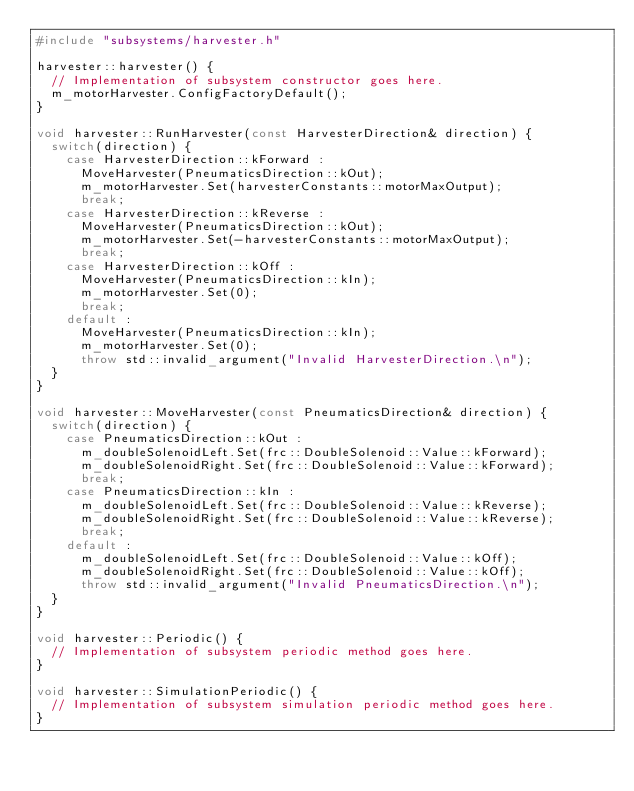<code> <loc_0><loc_0><loc_500><loc_500><_C++_>#include "subsystems/harvester.h"

harvester::harvester() {
  // Implementation of subsystem constructor goes here.
  m_motorHarvester.ConfigFactoryDefault();
}

void harvester::RunHarvester(const HarvesterDirection& direction) {
  switch(direction) {
    case HarvesterDirection::kForward :
      MoveHarvester(PneumaticsDirection::kOut);
      m_motorHarvester.Set(harvesterConstants::motorMaxOutput);
      break;
    case HarvesterDirection::kReverse :
      MoveHarvester(PneumaticsDirection::kOut);
      m_motorHarvester.Set(-harvesterConstants::motorMaxOutput);
      break;
    case HarvesterDirection::kOff :
      MoveHarvester(PneumaticsDirection::kIn);
      m_motorHarvester.Set(0);
      break;
    default :
      MoveHarvester(PneumaticsDirection::kIn);
      m_motorHarvester.Set(0);
      throw std::invalid_argument("Invalid HarvesterDirection.\n");
  }
}

void harvester::MoveHarvester(const PneumaticsDirection& direction) {
  switch(direction) {
    case PneumaticsDirection::kOut :
      m_doubleSolenoidLeft.Set(frc::DoubleSolenoid::Value::kForward);
      m_doubleSolenoidRight.Set(frc::DoubleSolenoid::Value::kForward);
      break;
    case PneumaticsDirection::kIn :
      m_doubleSolenoidLeft.Set(frc::DoubleSolenoid::Value::kReverse);
      m_doubleSolenoidRight.Set(frc::DoubleSolenoid::Value::kReverse);
      break;
    default :
      m_doubleSolenoidLeft.Set(frc::DoubleSolenoid::Value::kOff);
      m_doubleSolenoidRight.Set(frc::DoubleSolenoid::Value::kOff);
      throw std::invalid_argument("Invalid PneumaticsDirection.\n");
  }
}

void harvester::Periodic() {
  // Implementation of subsystem periodic method goes here.
}

void harvester::SimulationPeriodic() {
  // Implementation of subsystem simulation periodic method goes here.
}
</code> 